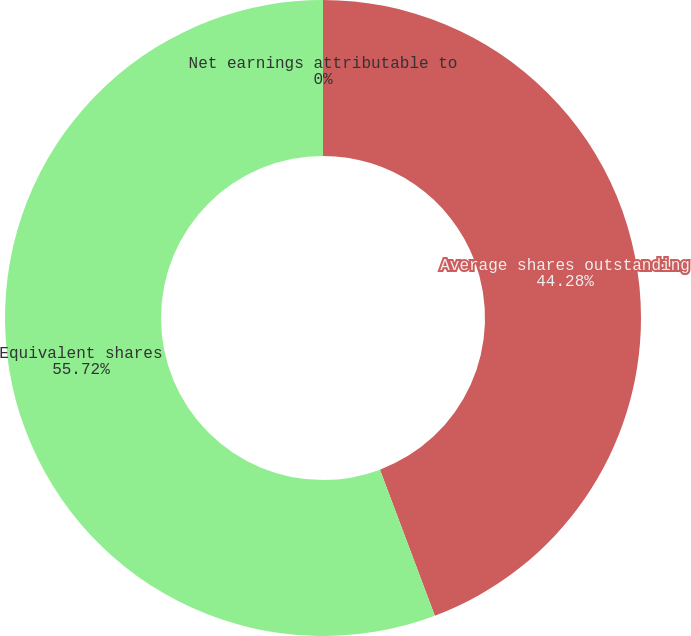Convert chart to OTSL. <chart><loc_0><loc_0><loc_500><loc_500><pie_chart><fcel>Net earnings attributable to<fcel>Average shares outstanding<fcel>Equivalent shares<nl><fcel>0.0%<fcel>44.28%<fcel>55.72%<nl></chart> 